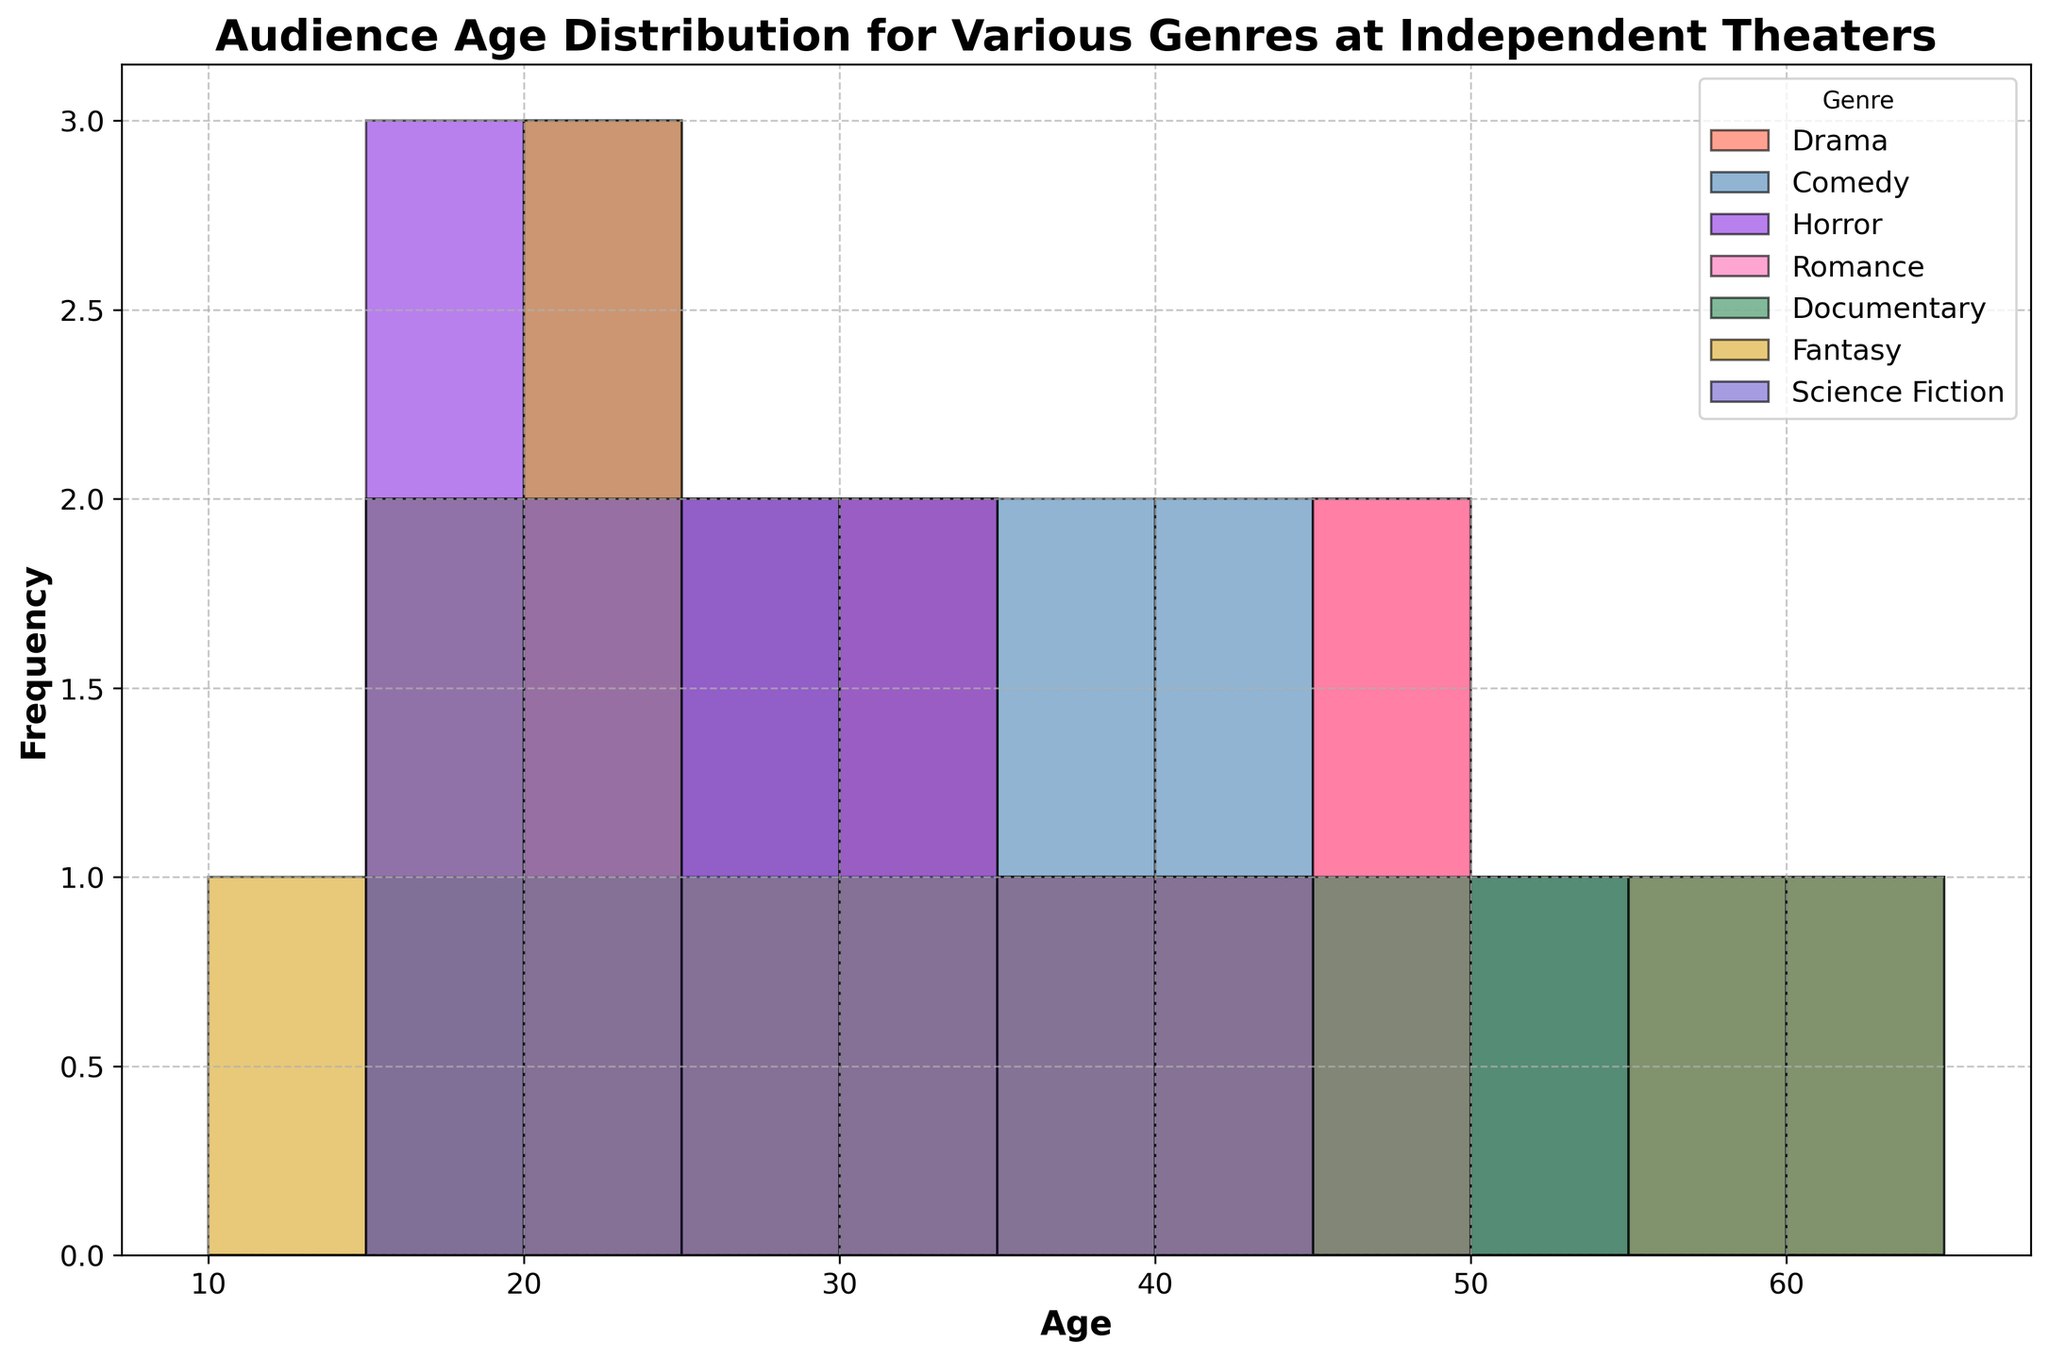What genre has the youngest audience in general? The histogram shows that Fantasy and Horror have the youngest age bins starting as low as 14 and 16 respectively. Romance and Horror also feature some young audience members but not as young as Fantasy.
Answer: Fantasy Which genre has the highest peak in audience age distribution? The highest peak means the tallest bar in the histogram. From the visual representation, Drama has the tallest bar, indicating the highest concentration of viewers in a particular age range around 34-45.
Answer: Drama Compare the average age of the Comedy and Horror audience. Which one is higher? To estimate the average age, look at the spread and peak of the audience age distribution. Comedy has a spread from 18 to 50 with a higher concentration around 28-35, while Horror ranges from 16 to 33. This visual assessment suggests Comedy has a higher average age.
Answer: Comedy What age range does Documentary cater to the most? By looking at the histogram bars for Documentary, we see that the tallest bars are in the range from 30 to 60, indicating this is the most common age group for Documentary viewers.
Answer: 30-60 Which genre has the widest age distribution? The widest age distribution would stretch from the youngest to the oldest age brackets in the histogram. Documentary and Drama both span a broad range from 18 to 60, but Science Fiction spans from 16 to 42, so Documentary appears to have the widest spread.
Answer: Documentary Which genre has the least amount of variation in audience age? The least variation would mean the tightest cluster of age range. Horror's ages tightly range between 16 to 33, indicating it has the least variation.
Answer: Horror What’s the most common age range for Romance moviegoers? Observing the tallest bars within the Romance genre, they peak around 28-35, indicating this is the most common age range for Romance viewers.
Answer: 28-35 How does the distribution of Science Fiction audiences differ from that of Fantasy audiences? Science Fiction shows a more evenly distributed audience from 16 to 42 without very tall peaks, suggesting a spread out interest. Fantasy, however, peaks predominantly around the younger end from 14 to 32.
Answer: Science Fiction is more evenly distributed; Fantasy peaks younger Which genres have audience distributions that significantly overlap? To determine overlapping, look for genres with similar age distributions. Drama and Documentary show significant overlap, both catering heavily to the 25-60 age range.
Answer: Drama and Documentary What common feature do Drama and Documentary have regarding age distribution? Both Drama and Documentary have bars that peak significantly in the older age ranges, particularly from 30 and above, indicating a preference among older audiences.
Answer: Older age preference 